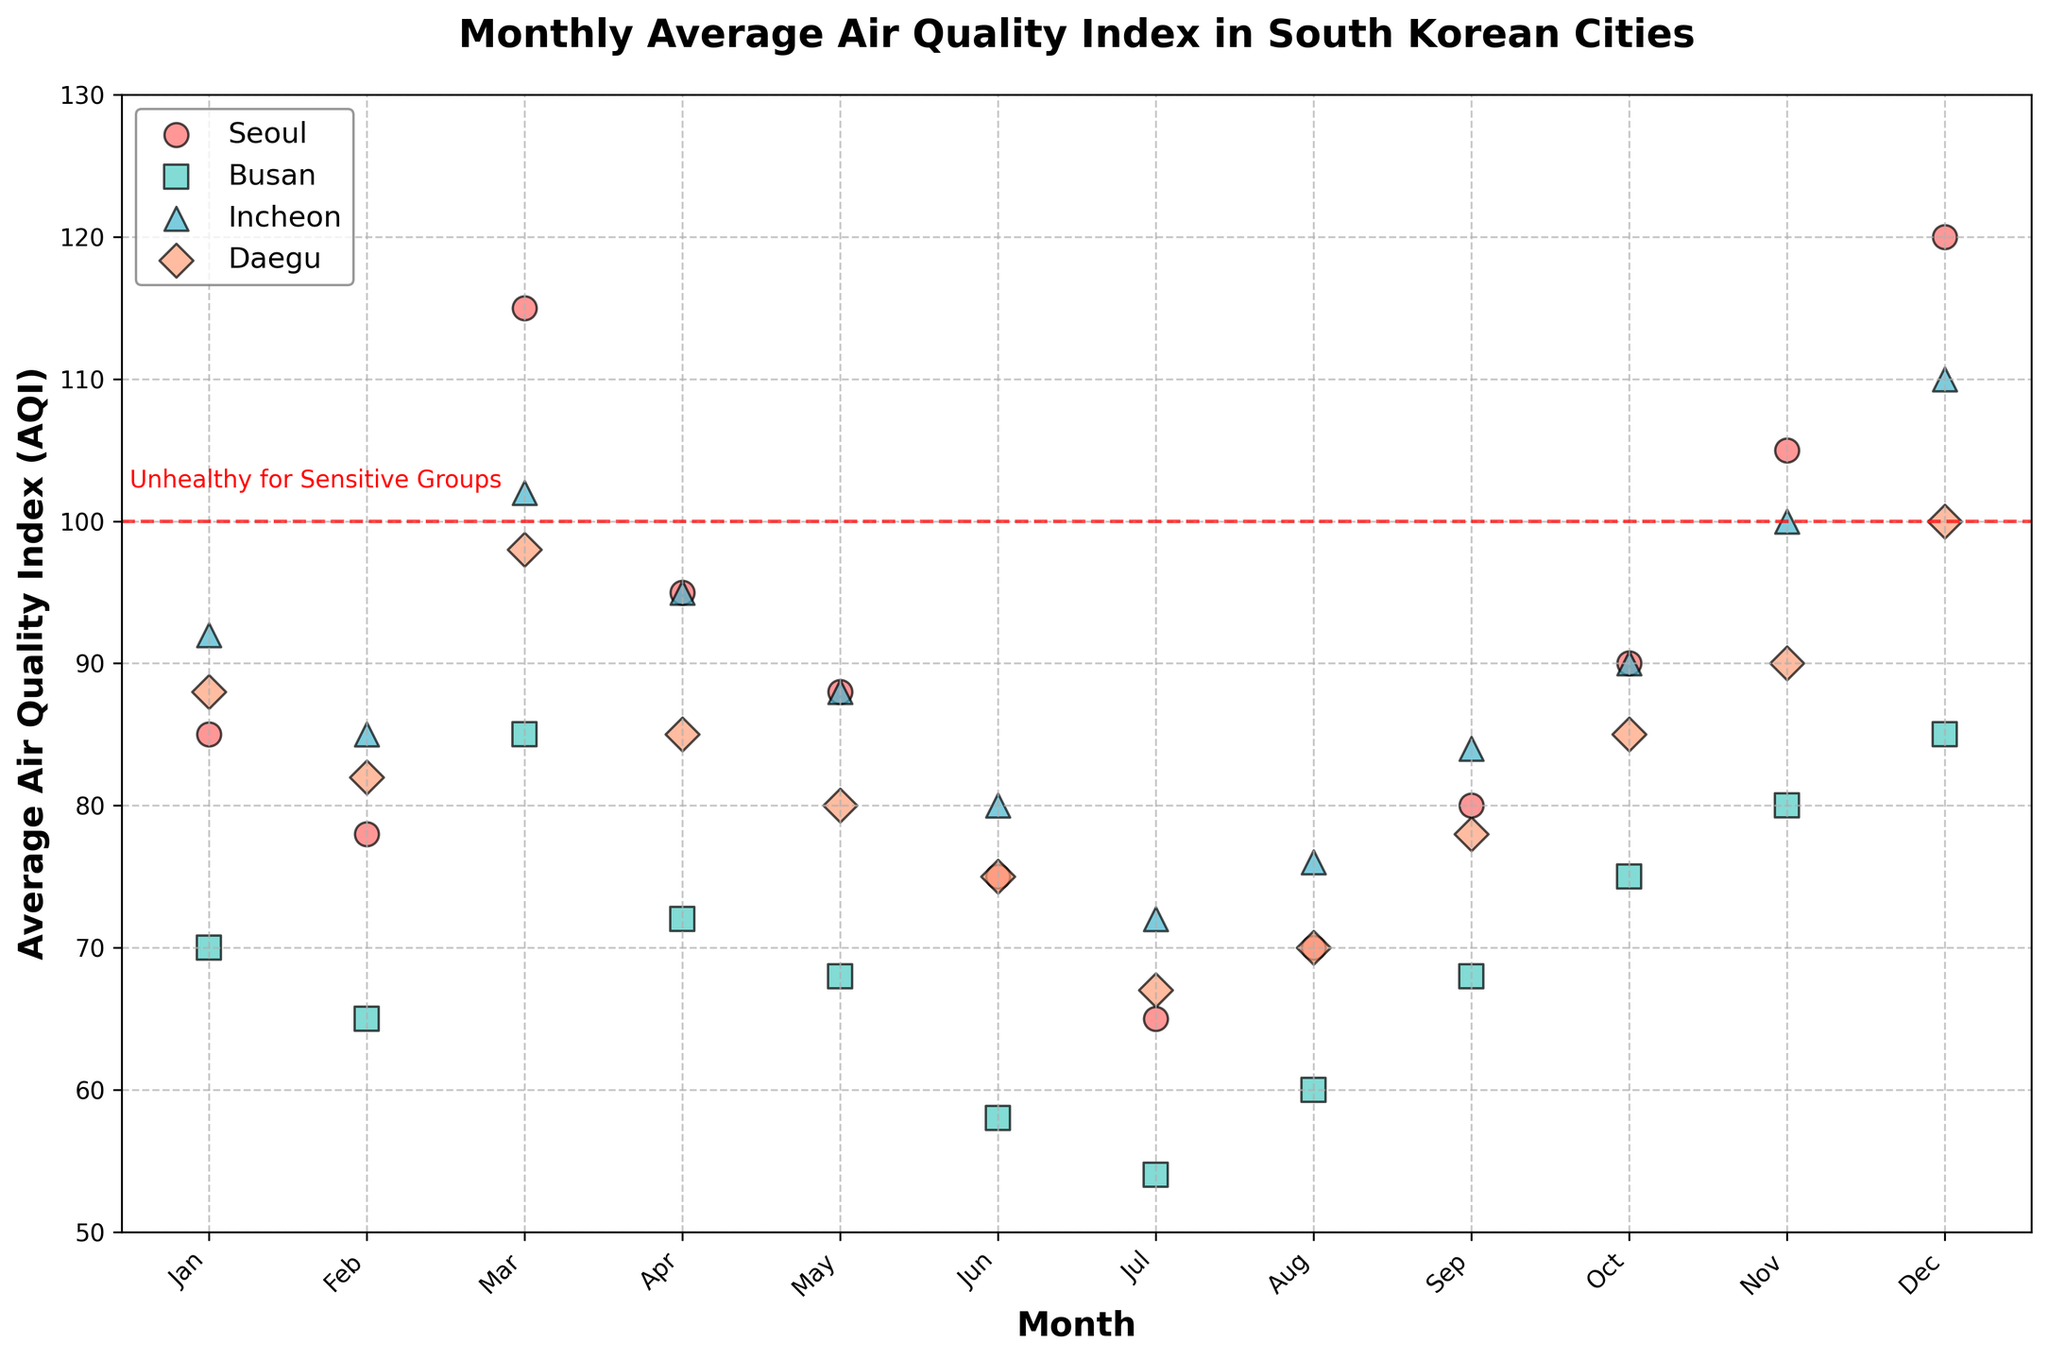What is the title of the scatter plot? The title is located at the top center of the scatter plot and is in bold font.
Answer: Monthly Average Air Quality Index in South Korean Cities How does the AQI trend in Busan change throughout the year? Look for the scatter plot points that correspond to Busan. Plot points for Busan are colored with a specific color and have a consistent marker shape. Trace these markers across each month's location on the x-axis.
Answer: Generally decreases from January to July, then increases towards December In which month does Seoul have its highest AQI? Identify the scatter points associated with Seoul. Check which point among these is highest on the y-axis. Identify the corresponding month on the x-axis.
Answer: December Which city has the most occurrences of the "Unhealthy for Sensitive Groups" AQI impact throughout the year? Examine the colored scatter points and count the occurrences for each city that cross the red dashed line at AQI=100, indicating the threshold for "Unhealthy for Sensitive Groups".
Answer: Seoul Comparing July's AQI in Seoul and Daegu, which city has a lower value? Find the points for July on the x-axis for both actual cities' data, then compare their y-axis values.
Answer: Daegu What visual indication is there for identifying the AQI value that makes air "Unhealthy for Sensitive Groups"? There is a visual element that highlights a significant AQI value. It is a red dashed line at the AQI value of 100.
Answer: Red dashed line at AQI=100 On average, which months have moderate AQI levels for Incheon? First, list the AQI values for each month for Incheon. Then identify the number of months where AQI values fall below the red dashed line at 100, indicating Moderate.
Answer: January, February, April, May, June, July, August, September, October How do the AQI values of January compare among all four cities? Identify the AQI values for January for each city. Compare these values to determine which cities have highest/lowest.
Answer: Seoul: 85, Busan: 70, Incheon: 92, Daegu: 88 Which city has the steepest decline in AQI from March to April? Identify the AQI values for March and April for each city, then calculate the differences. Compare the differences to determine the steepest decline.
Answer: Busan 